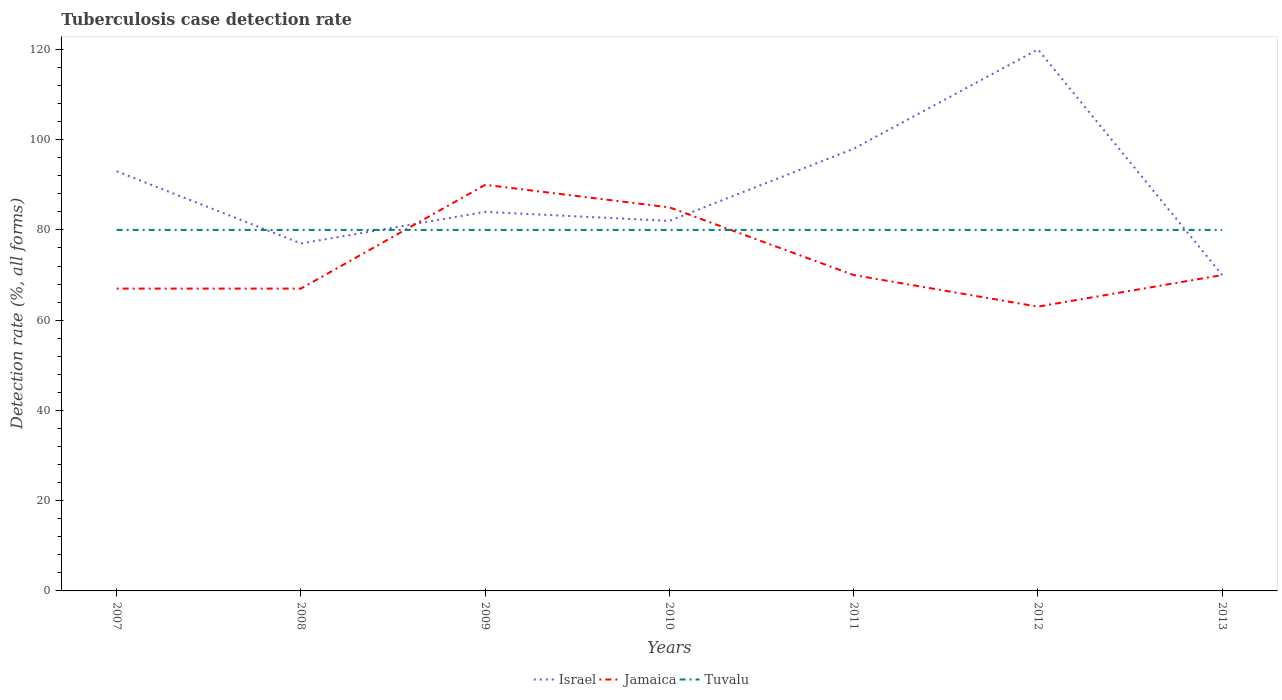Does the line corresponding to Jamaica intersect with the line corresponding to Tuvalu?
Offer a terse response. Yes. Is the number of lines equal to the number of legend labels?
Provide a short and direct response. Yes. Across all years, what is the maximum tuberculosis case detection rate in in Jamaica?
Offer a very short reply. 63. Does the graph contain any zero values?
Offer a very short reply. No. Where does the legend appear in the graph?
Keep it short and to the point. Bottom center. What is the title of the graph?
Provide a succinct answer. Tuberculosis case detection rate. What is the label or title of the X-axis?
Make the answer very short. Years. What is the label or title of the Y-axis?
Keep it short and to the point. Detection rate (%, all forms). What is the Detection rate (%, all forms) of Israel in 2007?
Offer a terse response. 93. What is the Detection rate (%, all forms) in Tuvalu in 2007?
Give a very brief answer. 80. What is the Detection rate (%, all forms) in Tuvalu in 2008?
Keep it short and to the point. 80. What is the Detection rate (%, all forms) of Israel in 2009?
Keep it short and to the point. 84. What is the Detection rate (%, all forms) of Jamaica in 2009?
Give a very brief answer. 90. What is the Detection rate (%, all forms) of Israel in 2010?
Make the answer very short. 82. What is the Detection rate (%, all forms) of Jamaica in 2010?
Keep it short and to the point. 85. What is the Detection rate (%, all forms) in Tuvalu in 2010?
Provide a short and direct response. 80. What is the Detection rate (%, all forms) in Israel in 2011?
Offer a very short reply. 98. What is the Detection rate (%, all forms) in Israel in 2012?
Ensure brevity in your answer.  120. What is the Detection rate (%, all forms) in Tuvalu in 2012?
Keep it short and to the point. 80. What is the Detection rate (%, all forms) in Israel in 2013?
Make the answer very short. 70. Across all years, what is the maximum Detection rate (%, all forms) of Israel?
Offer a very short reply. 120. Across all years, what is the minimum Detection rate (%, all forms) of Israel?
Your answer should be very brief. 70. What is the total Detection rate (%, all forms) in Israel in the graph?
Offer a terse response. 624. What is the total Detection rate (%, all forms) of Jamaica in the graph?
Your answer should be very brief. 512. What is the total Detection rate (%, all forms) of Tuvalu in the graph?
Make the answer very short. 560. What is the difference between the Detection rate (%, all forms) in Israel in 2007 and that in 2008?
Your answer should be compact. 16. What is the difference between the Detection rate (%, all forms) of Jamaica in 2007 and that in 2008?
Your response must be concise. 0. What is the difference between the Detection rate (%, all forms) in Tuvalu in 2007 and that in 2008?
Provide a short and direct response. 0. What is the difference between the Detection rate (%, all forms) in Jamaica in 2007 and that in 2009?
Offer a very short reply. -23. What is the difference between the Detection rate (%, all forms) in Tuvalu in 2007 and that in 2009?
Your answer should be compact. 0. What is the difference between the Detection rate (%, all forms) in Jamaica in 2007 and that in 2010?
Your answer should be compact. -18. What is the difference between the Detection rate (%, all forms) of Tuvalu in 2007 and that in 2010?
Your answer should be compact. 0. What is the difference between the Detection rate (%, all forms) of Jamaica in 2007 and that in 2011?
Your response must be concise. -3. What is the difference between the Detection rate (%, all forms) of Tuvalu in 2007 and that in 2011?
Provide a succinct answer. 0. What is the difference between the Detection rate (%, all forms) in Tuvalu in 2007 and that in 2012?
Offer a very short reply. 0. What is the difference between the Detection rate (%, all forms) of Israel in 2007 and that in 2013?
Provide a short and direct response. 23. What is the difference between the Detection rate (%, all forms) in Jamaica in 2008 and that in 2009?
Provide a succinct answer. -23. What is the difference between the Detection rate (%, all forms) in Israel in 2008 and that in 2010?
Ensure brevity in your answer.  -5. What is the difference between the Detection rate (%, all forms) of Jamaica in 2008 and that in 2010?
Your response must be concise. -18. What is the difference between the Detection rate (%, all forms) in Tuvalu in 2008 and that in 2010?
Offer a very short reply. 0. What is the difference between the Detection rate (%, all forms) of Israel in 2008 and that in 2011?
Make the answer very short. -21. What is the difference between the Detection rate (%, all forms) of Israel in 2008 and that in 2012?
Make the answer very short. -43. What is the difference between the Detection rate (%, all forms) of Jamaica in 2008 and that in 2012?
Your answer should be very brief. 4. What is the difference between the Detection rate (%, all forms) of Jamaica in 2008 and that in 2013?
Provide a succinct answer. -3. What is the difference between the Detection rate (%, all forms) in Tuvalu in 2008 and that in 2013?
Your response must be concise. 0. What is the difference between the Detection rate (%, all forms) of Tuvalu in 2009 and that in 2010?
Offer a very short reply. 0. What is the difference between the Detection rate (%, all forms) in Israel in 2009 and that in 2011?
Offer a very short reply. -14. What is the difference between the Detection rate (%, all forms) in Israel in 2009 and that in 2012?
Your response must be concise. -36. What is the difference between the Detection rate (%, all forms) in Jamaica in 2009 and that in 2012?
Offer a terse response. 27. What is the difference between the Detection rate (%, all forms) of Israel in 2009 and that in 2013?
Provide a succinct answer. 14. What is the difference between the Detection rate (%, all forms) of Jamaica in 2009 and that in 2013?
Offer a very short reply. 20. What is the difference between the Detection rate (%, all forms) in Tuvalu in 2009 and that in 2013?
Provide a short and direct response. 0. What is the difference between the Detection rate (%, all forms) of Israel in 2010 and that in 2011?
Make the answer very short. -16. What is the difference between the Detection rate (%, all forms) in Tuvalu in 2010 and that in 2011?
Ensure brevity in your answer.  0. What is the difference between the Detection rate (%, all forms) in Israel in 2010 and that in 2012?
Provide a succinct answer. -38. What is the difference between the Detection rate (%, all forms) of Tuvalu in 2010 and that in 2012?
Your response must be concise. 0. What is the difference between the Detection rate (%, all forms) of Jamaica in 2010 and that in 2013?
Offer a terse response. 15. What is the difference between the Detection rate (%, all forms) of Tuvalu in 2010 and that in 2013?
Make the answer very short. 0. What is the difference between the Detection rate (%, all forms) in Israel in 2011 and that in 2012?
Keep it short and to the point. -22. What is the difference between the Detection rate (%, all forms) in Israel in 2011 and that in 2013?
Ensure brevity in your answer.  28. What is the difference between the Detection rate (%, all forms) in Israel in 2012 and that in 2013?
Keep it short and to the point. 50. What is the difference between the Detection rate (%, all forms) of Tuvalu in 2012 and that in 2013?
Provide a succinct answer. 0. What is the difference between the Detection rate (%, all forms) of Jamaica in 2007 and the Detection rate (%, all forms) of Tuvalu in 2008?
Ensure brevity in your answer.  -13. What is the difference between the Detection rate (%, all forms) in Israel in 2007 and the Detection rate (%, all forms) in Tuvalu in 2009?
Make the answer very short. 13. What is the difference between the Detection rate (%, all forms) of Jamaica in 2007 and the Detection rate (%, all forms) of Tuvalu in 2009?
Keep it short and to the point. -13. What is the difference between the Detection rate (%, all forms) in Jamaica in 2007 and the Detection rate (%, all forms) in Tuvalu in 2010?
Your response must be concise. -13. What is the difference between the Detection rate (%, all forms) of Jamaica in 2007 and the Detection rate (%, all forms) of Tuvalu in 2011?
Make the answer very short. -13. What is the difference between the Detection rate (%, all forms) in Israel in 2007 and the Detection rate (%, all forms) in Jamaica in 2013?
Your answer should be compact. 23. What is the difference between the Detection rate (%, all forms) in Israel in 2007 and the Detection rate (%, all forms) in Tuvalu in 2013?
Offer a very short reply. 13. What is the difference between the Detection rate (%, all forms) of Israel in 2008 and the Detection rate (%, all forms) of Jamaica in 2009?
Offer a very short reply. -13. What is the difference between the Detection rate (%, all forms) of Israel in 2008 and the Detection rate (%, all forms) of Tuvalu in 2010?
Provide a short and direct response. -3. What is the difference between the Detection rate (%, all forms) in Jamaica in 2008 and the Detection rate (%, all forms) in Tuvalu in 2010?
Your answer should be very brief. -13. What is the difference between the Detection rate (%, all forms) in Israel in 2008 and the Detection rate (%, all forms) in Tuvalu in 2011?
Provide a short and direct response. -3. What is the difference between the Detection rate (%, all forms) of Israel in 2008 and the Detection rate (%, all forms) of Jamaica in 2012?
Give a very brief answer. 14. What is the difference between the Detection rate (%, all forms) in Israel in 2008 and the Detection rate (%, all forms) in Tuvalu in 2012?
Your response must be concise. -3. What is the difference between the Detection rate (%, all forms) in Jamaica in 2008 and the Detection rate (%, all forms) in Tuvalu in 2012?
Keep it short and to the point. -13. What is the difference between the Detection rate (%, all forms) in Israel in 2009 and the Detection rate (%, all forms) in Jamaica in 2010?
Keep it short and to the point. -1. What is the difference between the Detection rate (%, all forms) of Israel in 2009 and the Detection rate (%, all forms) of Tuvalu in 2010?
Provide a succinct answer. 4. What is the difference between the Detection rate (%, all forms) of Israel in 2009 and the Detection rate (%, all forms) of Jamaica in 2011?
Give a very brief answer. 14. What is the difference between the Detection rate (%, all forms) in Israel in 2009 and the Detection rate (%, all forms) in Tuvalu in 2011?
Your answer should be compact. 4. What is the difference between the Detection rate (%, all forms) of Jamaica in 2009 and the Detection rate (%, all forms) of Tuvalu in 2011?
Your answer should be very brief. 10. What is the difference between the Detection rate (%, all forms) of Israel in 2009 and the Detection rate (%, all forms) of Tuvalu in 2013?
Your answer should be compact. 4. What is the difference between the Detection rate (%, all forms) in Israel in 2010 and the Detection rate (%, all forms) in Jamaica in 2011?
Offer a very short reply. 12. What is the difference between the Detection rate (%, all forms) in Jamaica in 2010 and the Detection rate (%, all forms) in Tuvalu in 2011?
Provide a short and direct response. 5. What is the difference between the Detection rate (%, all forms) in Israel in 2010 and the Detection rate (%, all forms) in Jamaica in 2012?
Your answer should be very brief. 19. What is the difference between the Detection rate (%, all forms) of Israel in 2010 and the Detection rate (%, all forms) of Tuvalu in 2012?
Ensure brevity in your answer.  2. What is the difference between the Detection rate (%, all forms) of Jamaica in 2010 and the Detection rate (%, all forms) of Tuvalu in 2012?
Make the answer very short. 5. What is the difference between the Detection rate (%, all forms) of Israel in 2010 and the Detection rate (%, all forms) of Tuvalu in 2013?
Ensure brevity in your answer.  2. What is the difference between the Detection rate (%, all forms) of Jamaica in 2010 and the Detection rate (%, all forms) of Tuvalu in 2013?
Your response must be concise. 5. What is the difference between the Detection rate (%, all forms) of Jamaica in 2011 and the Detection rate (%, all forms) of Tuvalu in 2013?
Offer a terse response. -10. What is the difference between the Detection rate (%, all forms) in Israel in 2012 and the Detection rate (%, all forms) in Jamaica in 2013?
Your answer should be very brief. 50. What is the average Detection rate (%, all forms) of Israel per year?
Ensure brevity in your answer.  89.14. What is the average Detection rate (%, all forms) of Jamaica per year?
Ensure brevity in your answer.  73.14. In the year 2007, what is the difference between the Detection rate (%, all forms) of Israel and Detection rate (%, all forms) of Jamaica?
Provide a succinct answer. 26. In the year 2009, what is the difference between the Detection rate (%, all forms) in Israel and Detection rate (%, all forms) in Jamaica?
Ensure brevity in your answer.  -6. In the year 2009, what is the difference between the Detection rate (%, all forms) of Jamaica and Detection rate (%, all forms) of Tuvalu?
Your response must be concise. 10. In the year 2010, what is the difference between the Detection rate (%, all forms) of Israel and Detection rate (%, all forms) of Jamaica?
Your answer should be compact. -3. In the year 2011, what is the difference between the Detection rate (%, all forms) in Israel and Detection rate (%, all forms) in Jamaica?
Keep it short and to the point. 28. In the year 2011, what is the difference between the Detection rate (%, all forms) of Jamaica and Detection rate (%, all forms) of Tuvalu?
Give a very brief answer. -10. In the year 2012, what is the difference between the Detection rate (%, all forms) in Israel and Detection rate (%, all forms) in Jamaica?
Make the answer very short. 57. In the year 2012, what is the difference between the Detection rate (%, all forms) in Israel and Detection rate (%, all forms) in Tuvalu?
Provide a short and direct response. 40. In the year 2013, what is the difference between the Detection rate (%, all forms) of Israel and Detection rate (%, all forms) of Jamaica?
Give a very brief answer. 0. In the year 2013, what is the difference between the Detection rate (%, all forms) of Israel and Detection rate (%, all forms) of Tuvalu?
Your response must be concise. -10. What is the ratio of the Detection rate (%, all forms) of Israel in 2007 to that in 2008?
Provide a succinct answer. 1.21. What is the ratio of the Detection rate (%, all forms) in Tuvalu in 2007 to that in 2008?
Make the answer very short. 1. What is the ratio of the Detection rate (%, all forms) in Israel in 2007 to that in 2009?
Provide a succinct answer. 1.11. What is the ratio of the Detection rate (%, all forms) of Jamaica in 2007 to that in 2009?
Provide a short and direct response. 0.74. What is the ratio of the Detection rate (%, all forms) in Israel in 2007 to that in 2010?
Your response must be concise. 1.13. What is the ratio of the Detection rate (%, all forms) of Jamaica in 2007 to that in 2010?
Keep it short and to the point. 0.79. What is the ratio of the Detection rate (%, all forms) of Israel in 2007 to that in 2011?
Keep it short and to the point. 0.95. What is the ratio of the Detection rate (%, all forms) in Jamaica in 2007 to that in 2011?
Your response must be concise. 0.96. What is the ratio of the Detection rate (%, all forms) of Israel in 2007 to that in 2012?
Make the answer very short. 0.78. What is the ratio of the Detection rate (%, all forms) in Jamaica in 2007 to that in 2012?
Offer a very short reply. 1.06. What is the ratio of the Detection rate (%, all forms) of Israel in 2007 to that in 2013?
Your answer should be compact. 1.33. What is the ratio of the Detection rate (%, all forms) of Jamaica in 2007 to that in 2013?
Keep it short and to the point. 0.96. What is the ratio of the Detection rate (%, all forms) of Jamaica in 2008 to that in 2009?
Your response must be concise. 0.74. What is the ratio of the Detection rate (%, all forms) of Israel in 2008 to that in 2010?
Offer a very short reply. 0.94. What is the ratio of the Detection rate (%, all forms) of Jamaica in 2008 to that in 2010?
Provide a short and direct response. 0.79. What is the ratio of the Detection rate (%, all forms) of Israel in 2008 to that in 2011?
Your response must be concise. 0.79. What is the ratio of the Detection rate (%, all forms) of Jamaica in 2008 to that in 2011?
Keep it short and to the point. 0.96. What is the ratio of the Detection rate (%, all forms) of Israel in 2008 to that in 2012?
Give a very brief answer. 0.64. What is the ratio of the Detection rate (%, all forms) of Jamaica in 2008 to that in 2012?
Offer a terse response. 1.06. What is the ratio of the Detection rate (%, all forms) in Tuvalu in 2008 to that in 2012?
Provide a succinct answer. 1. What is the ratio of the Detection rate (%, all forms) of Jamaica in 2008 to that in 2013?
Your answer should be very brief. 0.96. What is the ratio of the Detection rate (%, all forms) in Tuvalu in 2008 to that in 2013?
Ensure brevity in your answer.  1. What is the ratio of the Detection rate (%, all forms) of Israel in 2009 to that in 2010?
Your response must be concise. 1.02. What is the ratio of the Detection rate (%, all forms) in Jamaica in 2009 to that in 2010?
Keep it short and to the point. 1.06. What is the ratio of the Detection rate (%, all forms) of Jamaica in 2009 to that in 2012?
Give a very brief answer. 1.43. What is the ratio of the Detection rate (%, all forms) in Tuvalu in 2009 to that in 2012?
Your answer should be very brief. 1. What is the ratio of the Detection rate (%, all forms) of Israel in 2009 to that in 2013?
Offer a terse response. 1.2. What is the ratio of the Detection rate (%, all forms) of Israel in 2010 to that in 2011?
Ensure brevity in your answer.  0.84. What is the ratio of the Detection rate (%, all forms) of Jamaica in 2010 to that in 2011?
Your answer should be very brief. 1.21. What is the ratio of the Detection rate (%, all forms) in Israel in 2010 to that in 2012?
Provide a succinct answer. 0.68. What is the ratio of the Detection rate (%, all forms) in Jamaica in 2010 to that in 2012?
Your answer should be compact. 1.35. What is the ratio of the Detection rate (%, all forms) in Tuvalu in 2010 to that in 2012?
Keep it short and to the point. 1. What is the ratio of the Detection rate (%, all forms) of Israel in 2010 to that in 2013?
Offer a terse response. 1.17. What is the ratio of the Detection rate (%, all forms) of Jamaica in 2010 to that in 2013?
Give a very brief answer. 1.21. What is the ratio of the Detection rate (%, all forms) of Tuvalu in 2010 to that in 2013?
Give a very brief answer. 1. What is the ratio of the Detection rate (%, all forms) in Israel in 2011 to that in 2012?
Keep it short and to the point. 0.82. What is the ratio of the Detection rate (%, all forms) of Tuvalu in 2011 to that in 2012?
Make the answer very short. 1. What is the ratio of the Detection rate (%, all forms) in Jamaica in 2011 to that in 2013?
Ensure brevity in your answer.  1. What is the ratio of the Detection rate (%, all forms) of Israel in 2012 to that in 2013?
Your response must be concise. 1.71. What is the ratio of the Detection rate (%, all forms) in Jamaica in 2012 to that in 2013?
Ensure brevity in your answer.  0.9. What is the ratio of the Detection rate (%, all forms) in Tuvalu in 2012 to that in 2013?
Keep it short and to the point. 1. What is the difference between the highest and the second highest Detection rate (%, all forms) in Israel?
Give a very brief answer. 22. What is the difference between the highest and the second highest Detection rate (%, all forms) of Jamaica?
Provide a succinct answer. 5. What is the difference between the highest and the lowest Detection rate (%, all forms) in Jamaica?
Your answer should be very brief. 27. What is the difference between the highest and the lowest Detection rate (%, all forms) of Tuvalu?
Provide a succinct answer. 0. 